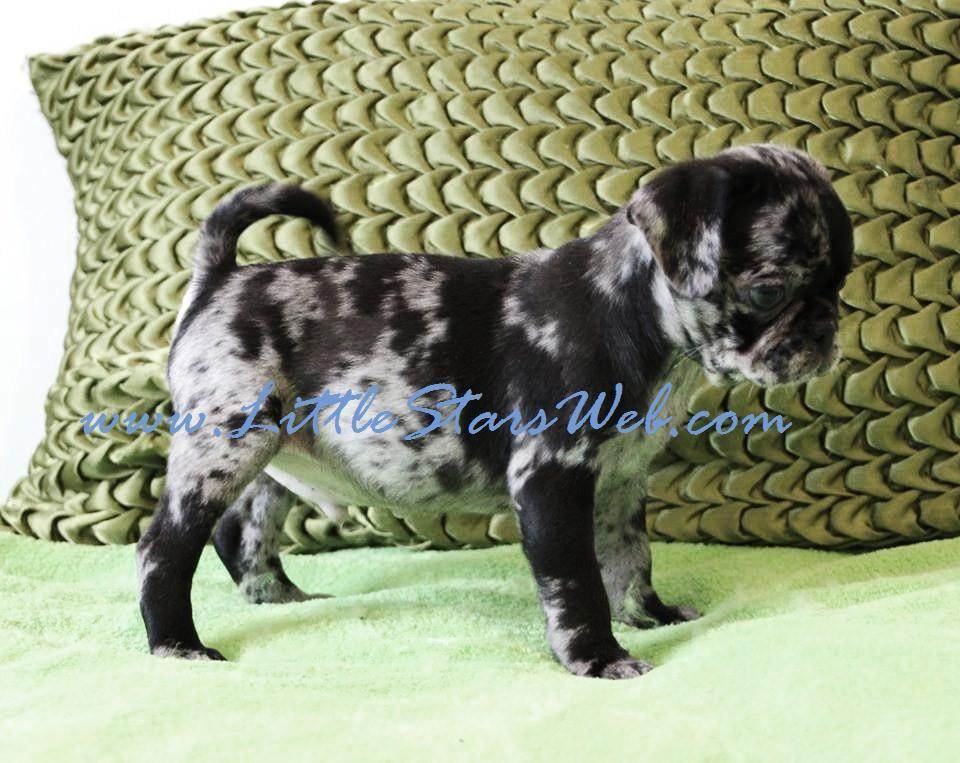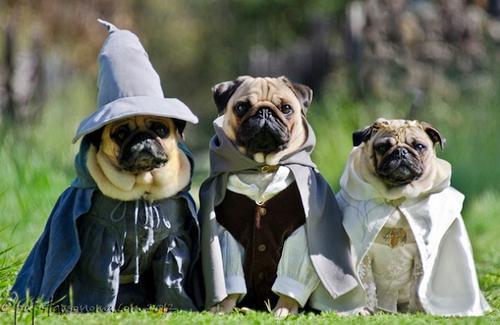The first image is the image on the left, the second image is the image on the right. For the images shown, is this caption "There are at least 3 dogs." true? Answer yes or no. Yes. The first image is the image on the left, the second image is the image on the right. For the images displayed, is the sentence "There are two pups here." factually correct? Answer yes or no. No. 